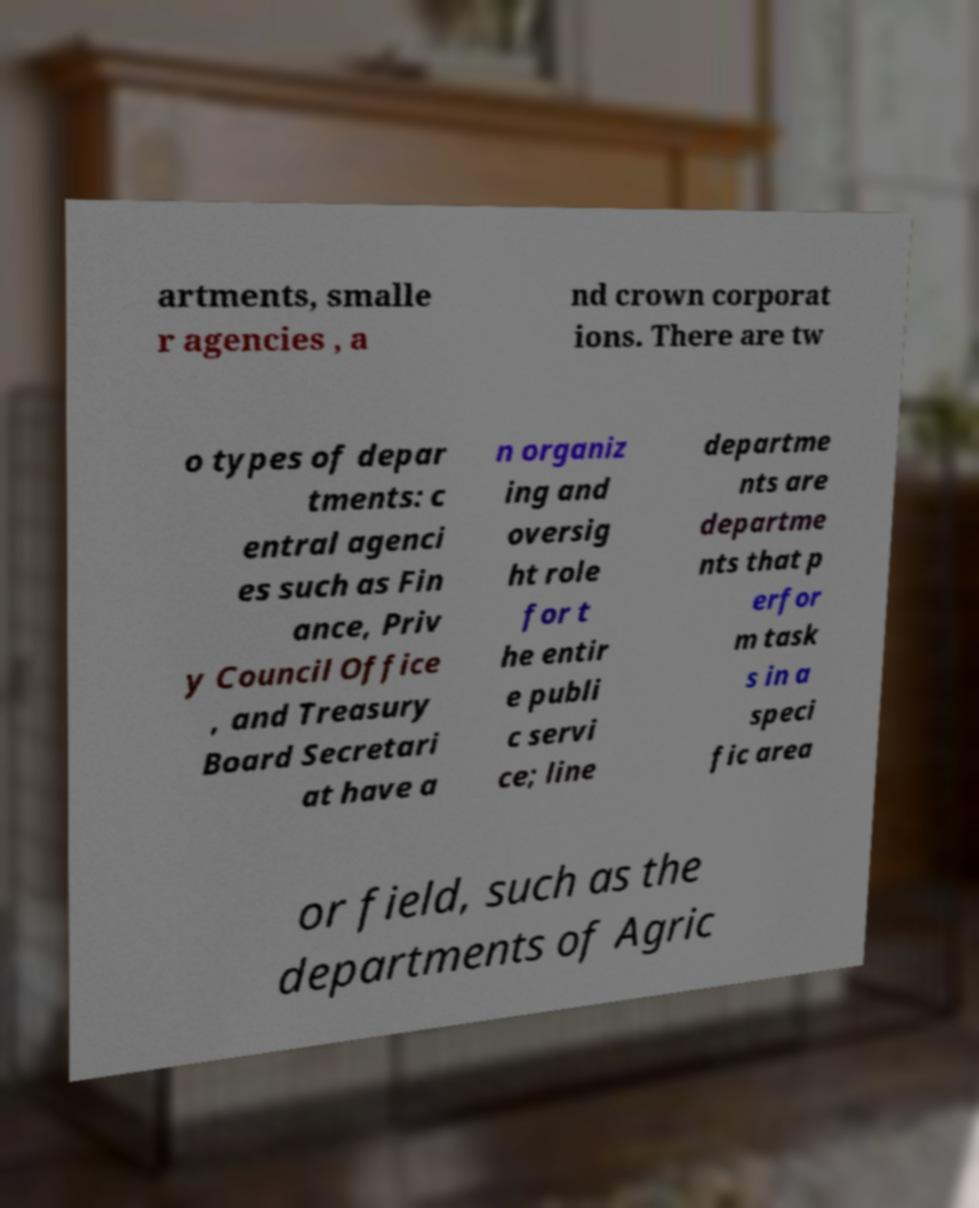Could you assist in decoding the text presented in this image and type it out clearly? artments, smalle r agencies , a nd crown corporat ions. There are tw o types of depar tments: c entral agenci es such as Fin ance, Priv y Council Office , and Treasury Board Secretari at have a n organiz ing and oversig ht role for t he entir e publi c servi ce; line departme nts are departme nts that p erfor m task s in a speci fic area or field, such as the departments of Agric 